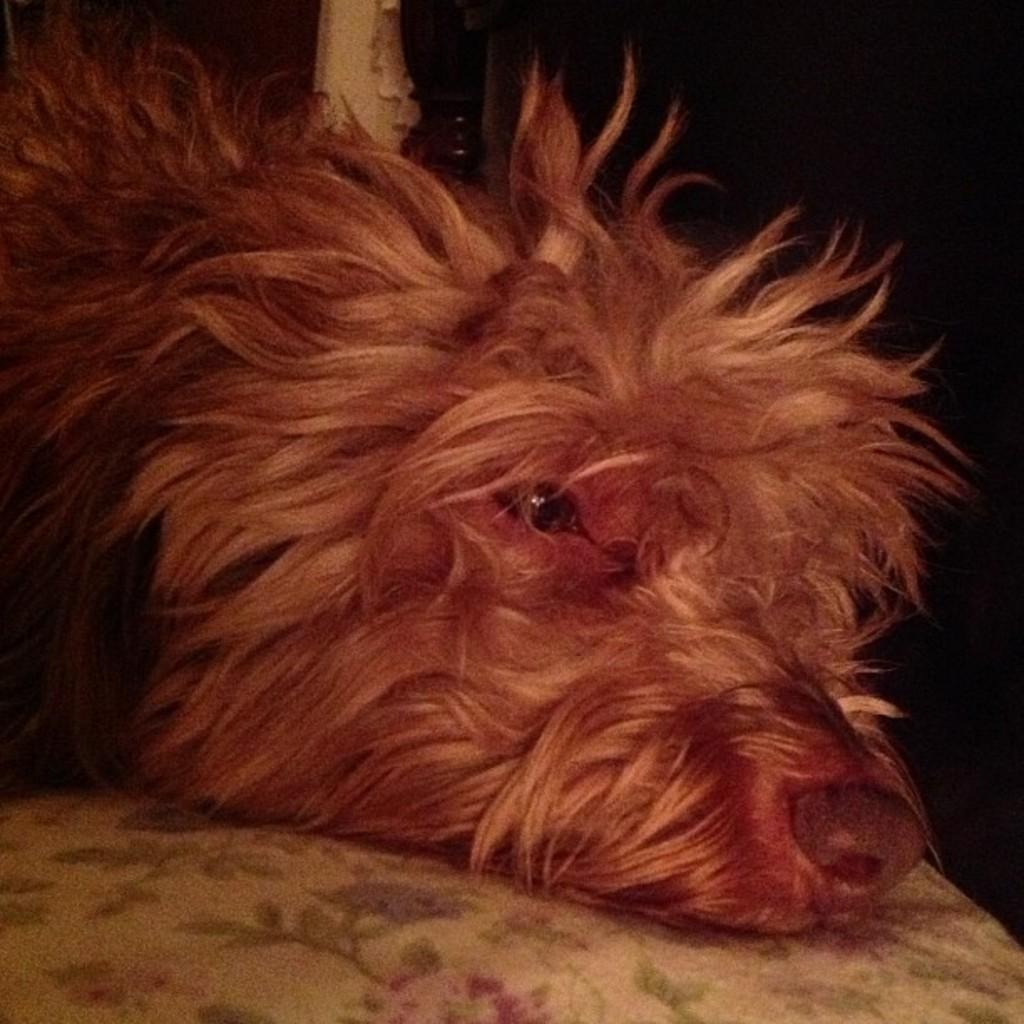What type of creature is present in the image? There is an animal in the image. Can you describe the color of the animal? The animal is gray in color. Is there a wound visible on the animal in the image? There is no mention of a wound in the provided facts, and therefore we cannot determine if one is present in the image. 